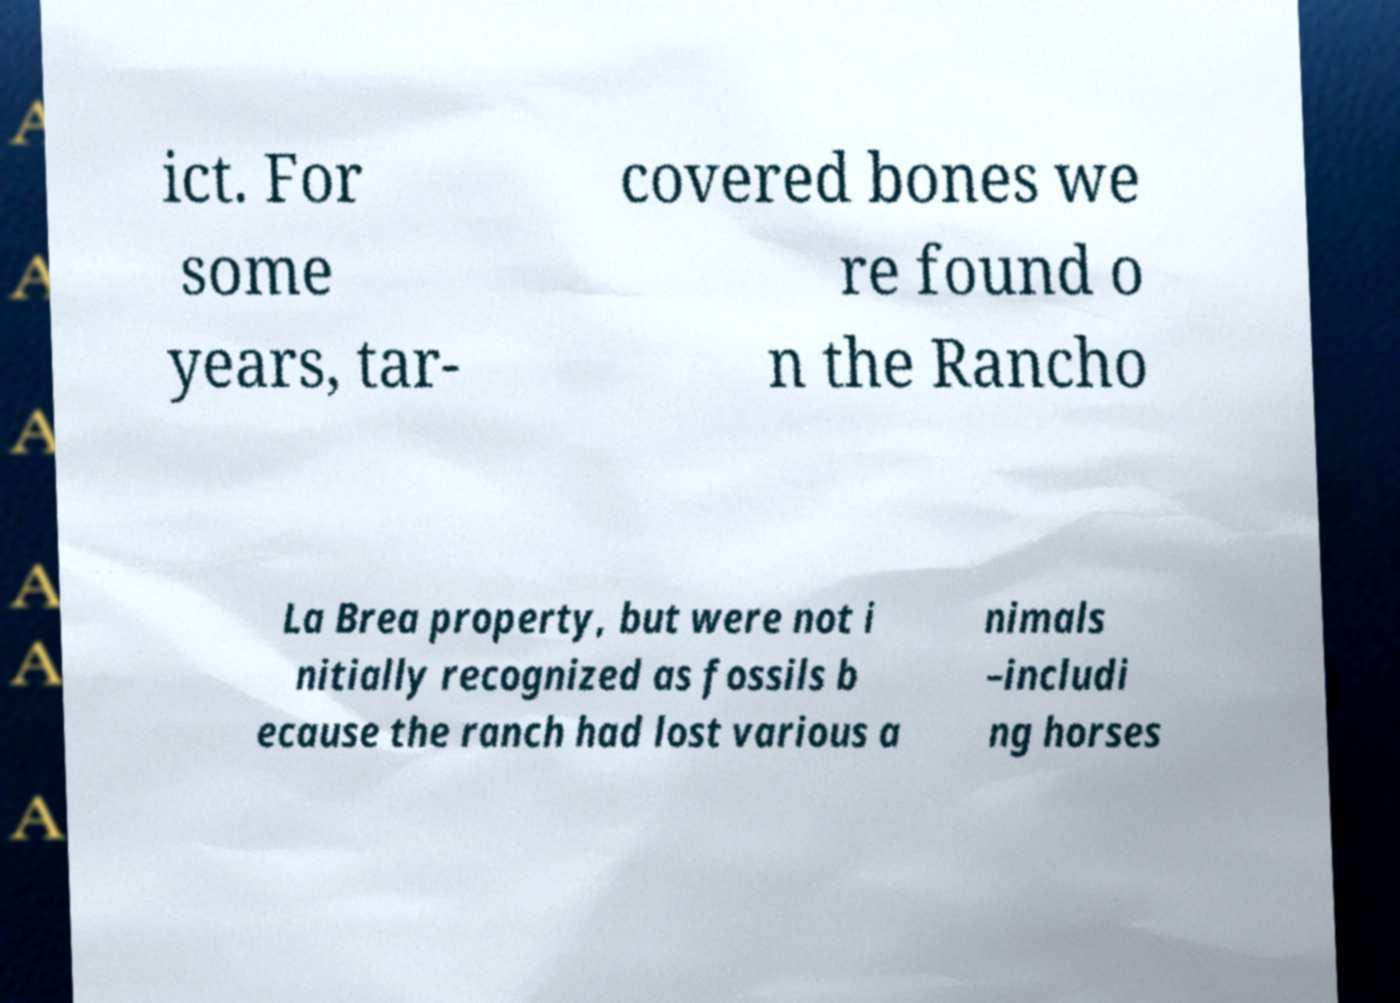Could you assist in decoding the text presented in this image and type it out clearly? ict. For some years, tar- covered bones we re found o n the Rancho La Brea property, but were not i nitially recognized as fossils b ecause the ranch had lost various a nimals –includi ng horses 